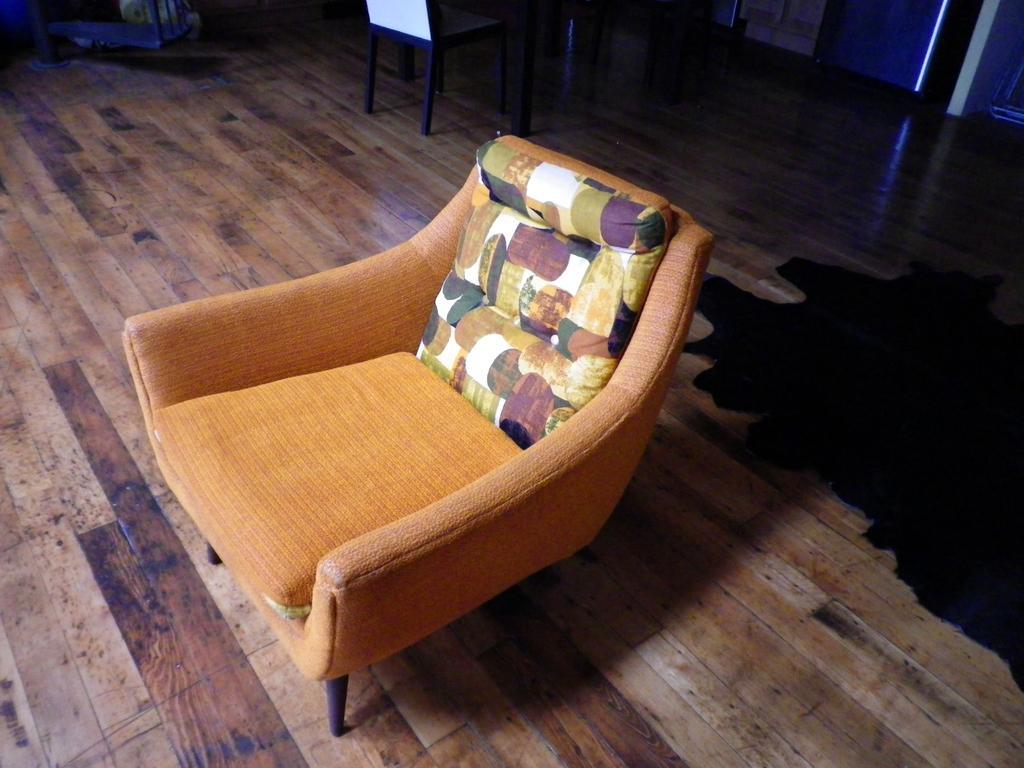Can you describe this image briefly? In the picture we can see a wooden floor on it we can see a chair with a pillow on it and behind it we can see another chair on the floor. 